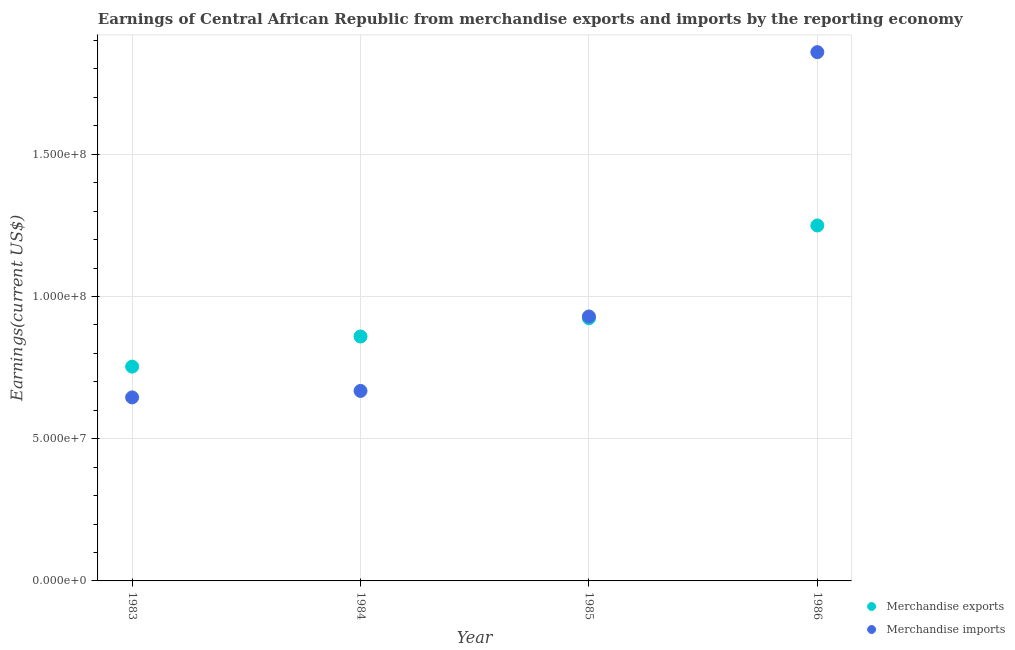Is the number of dotlines equal to the number of legend labels?
Your answer should be very brief. Yes. What is the earnings from merchandise imports in 1984?
Your answer should be compact. 6.68e+07. Across all years, what is the maximum earnings from merchandise exports?
Ensure brevity in your answer.  1.25e+08. Across all years, what is the minimum earnings from merchandise imports?
Offer a terse response. 6.45e+07. In which year was the earnings from merchandise exports maximum?
Keep it short and to the point. 1986. In which year was the earnings from merchandise imports minimum?
Your answer should be very brief. 1983. What is the total earnings from merchandise exports in the graph?
Make the answer very short. 3.79e+08. What is the difference between the earnings from merchandise imports in 1984 and that in 1986?
Your answer should be very brief. -1.19e+08. What is the difference between the earnings from merchandise exports in 1985 and the earnings from merchandise imports in 1984?
Provide a succinct answer. 2.55e+07. What is the average earnings from merchandise exports per year?
Give a very brief answer. 9.46e+07. In the year 1984, what is the difference between the earnings from merchandise imports and earnings from merchandise exports?
Offer a very short reply. -1.91e+07. In how many years, is the earnings from merchandise exports greater than 60000000 US$?
Ensure brevity in your answer.  4. What is the ratio of the earnings from merchandise exports in 1984 to that in 1985?
Provide a short and direct response. 0.93. What is the difference between the highest and the second highest earnings from merchandise imports?
Provide a succinct answer. 9.29e+07. What is the difference between the highest and the lowest earnings from merchandise imports?
Your answer should be compact. 1.21e+08. Is the sum of the earnings from merchandise imports in 1984 and 1985 greater than the maximum earnings from merchandise exports across all years?
Make the answer very short. Yes. Does the earnings from merchandise imports monotonically increase over the years?
Your answer should be very brief. Yes. How many dotlines are there?
Your answer should be compact. 2. How many years are there in the graph?
Make the answer very short. 4. Does the graph contain grids?
Give a very brief answer. Yes. Where does the legend appear in the graph?
Offer a very short reply. Bottom right. How many legend labels are there?
Provide a succinct answer. 2. How are the legend labels stacked?
Make the answer very short. Vertical. What is the title of the graph?
Make the answer very short. Earnings of Central African Republic from merchandise exports and imports by the reporting economy. What is the label or title of the Y-axis?
Provide a short and direct response. Earnings(current US$). What is the Earnings(current US$) in Merchandise exports in 1983?
Provide a short and direct response. 7.53e+07. What is the Earnings(current US$) of Merchandise imports in 1983?
Provide a succinct answer. 6.45e+07. What is the Earnings(current US$) in Merchandise exports in 1984?
Your answer should be very brief. 8.59e+07. What is the Earnings(current US$) of Merchandise imports in 1984?
Make the answer very short. 6.68e+07. What is the Earnings(current US$) in Merchandise exports in 1985?
Provide a succinct answer. 9.23e+07. What is the Earnings(current US$) of Merchandise imports in 1985?
Give a very brief answer. 9.30e+07. What is the Earnings(current US$) of Merchandise exports in 1986?
Make the answer very short. 1.25e+08. What is the Earnings(current US$) in Merchandise imports in 1986?
Offer a very short reply. 1.86e+08. Across all years, what is the maximum Earnings(current US$) in Merchandise exports?
Your answer should be compact. 1.25e+08. Across all years, what is the maximum Earnings(current US$) in Merchandise imports?
Offer a terse response. 1.86e+08. Across all years, what is the minimum Earnings(current US$) of Merchandise exports?
Offer a very short reply. 7.53e+07. Across all years, what is the minimum Earnings(current US$) of Merchandise imports?
Keep it short and to the point. 6.45e+07. What is the total Earnings(current US$) in Merchandise exports in the graph?
Make the answer very short. 3.79e+08. What is the total Earnings(current US$) in Merchandise imports in the graph?
Offer a very short reply. 4.10e+08. What is the difference between the Earnings(current US$) of Merchandise exports in 1983 and that in 1984?
Give a very brief answer. -1.06e+07. What is the difference between the Earnings(current US$) of Merchandise imports in 1983 and that in 1984?
Your response must be concise. -2.28e+06. What is the difference between the Earnings(current US$) in Merchandise exports in 1983 and that in 1985?
Ensure brevity in your answer.  -1.70e+07. What is the difference between the Earnings(current US$) in Merchandise imports in 1983 and that in 1985?
Your response must be concise. -2.85e+07. What is the difference between the Earnings(current US$) in Merchandise exports in 1983 and that in 1986?
Your answer should be compact. -4.96e+07. What is the difference between the Earnings(current US$) in Merchandise imports in 1983 and that in 1986?
Give a very brief answer. -1.21e+08. What is the difference between the Earnings(current US$) in Merchandise exports in 1984 and that in 1985?
Your answer should be very brief. -6.40e+06. What is the difference between the Earnings(current US$) of Merchandise imports in 1984 and that in 1985?
Provide a succinct answer. -2.62e+07. What is the difference between the Earnings(current US$) in Merchandise exports in 1984 and that in 1986?
Ensure brevity in your answer.  -3.90e+07. What is the difference between the Earnings(current US$) in Merchandise imports in 1984 and that in 1986?
Ensure brevity in your answer.  -1.19e+08. What is the difference between the Earnings(current US$) in Merchandise exports in 1985 and that in 1986?
Keep it short and to the point. -3.26e+07. What is the difference between the Earnings(current US$) of Merchandise imports in 1985 and that in 1986?
Your answer should be very brief. -9.29e+07. What is the difference between the Earnings(current US$) in Merchandise exports in 1983 and the Earnings(current US$) in Merchandise imports in 1984?
Offer a very short reply. 8.54e+06. What is the difference between the Earnings(current US$) in Merchandise exports in 1983 and the Earnings(current US$) in Merchandise imports in 1985?
Keep it short and to the point. -1.76e+07. What is the difference between the Earnings(current US$) of Merchandise exports in 1983 and the Earnings(current US$) of Merchandise imports in 1986?
Your response must be concise. -1.11e+08. What is the difference between the Earnings(current US$) of Merchandise exports in 1984 and the Earnings(current US$) of Merchandise imports in 1985?
Keep it short and to the point. -7.04e+06. What is the difference between the Earnings(current US$) of Merchandise exports in 1984 and the Earnings(current US$) of Merchandise imports in 1986?
Give a very brief answer. -1.00e+08. What is the difference between the Earnings(current US$) in Merchandise exports in 1985 and the Earnings(current US$) in Merchandise imports in 1986?
Ensure brevity in your answer.  -9.36e+07. What is the average Earnings(current US$) in Merchandise exports per year?
Make the answer very short. 9.46e+07. What is the average Earnings(current US$) in Merchandise imports per year?
Make the answer very short. 1.03e+08. In the year 1983, what is the difference between the Earnings(current US$) in Merchandise exports and Earnings(current US$) in Merchandise imports?
Offer a terse response. 1.08e+07. In the year 1984, what is the difference between the Earnings(current US$) in Merchandise exports and Earnings(current US$) in Merchandise imports?
Give a very brief answer. 1.91e+07. In the year 1985, what is the difference between the Earnings(current US$) in Merchandise exports and Earnings(current US$) in Merchandise imports?
Your answer should be compact. -6.39e+05. In the year 1986, what is the difference between the Earnings(current US$) in Merchandise exports and Earnings(current US$) in Merchandise imports?
Offer a very short reply. -6.09e+07. What is the ratio of the Earnings(current US$) in Merchandise exports in 1983 to that in 1984?
Keep it short and to the point. 0.88. What is the ratio of the Earnings(current US$) of Merchandise imports in 1983 to that in 1984?
Provide a succinct answer. 0.97. What is the ratio of the Earnings(current US$) of Merchandise exports in 1983 to that in 1985?
Your answer should be compact. 0.82. What is the ratio of the Earnings(current US$) of Merchandise imports in 1983 to that in 1985?
Keep it short and to the point. 0.69. What is the ratio of the Earnings(current US$) in Merchandise exports in 1983 to that in 1986?
Give a very brief answer. 0.6. What is the ratio of the Earnings(current US$) in Merchandise imports in 1983 to that in 1986?
Your answer should be compact. 0.35. What is the ratio of the Earnings(current US$) in Merchandise exports in 1984 to that in 1985?
Your answer should be compact. 0.93. What is the ratio of the Earnings(current US$) of Merchandise imports in 1984 to that in 1985?
Provide a short and direct response. 0.72. What is the ratio of the Earnings(current US$) of Merchandise exports in 1984 to that in 1986?
Offer a terse response. 0.69. What is the ratio of the Earnings(current US$) in Merchandise imports in 1984 to that in 1986?
Provide a succinct answer. 0.36. What is the ratio of the Earnings(current US$) in Merchandise exports in 1985 to that in 1986?
Provide a short and direct response. 0.74. What is the ratio of the Earnings(current US$) of Merchandise imports in 1985 to that in 1986?
Give a very brief answer. 0.5. What is the difference between the highest and the second highest Earnings(current US$) in Merchandise exports?
Your answer should be very brief. 3.26e+07. What is the difference between the highest and the second highest Earnings(current US$) in Merchandise imports?
Your answer should be compact. 9.29e+07. What is the difference between the highest and the lowest Earnings(current US$) of Merchandise exports?
Your response must be concise. 4.96e+07. What is the difference between the highest and the lowest Earnings(current US$) of Merchandise imports?
Your answer should be very brief. 1.21e+08. 